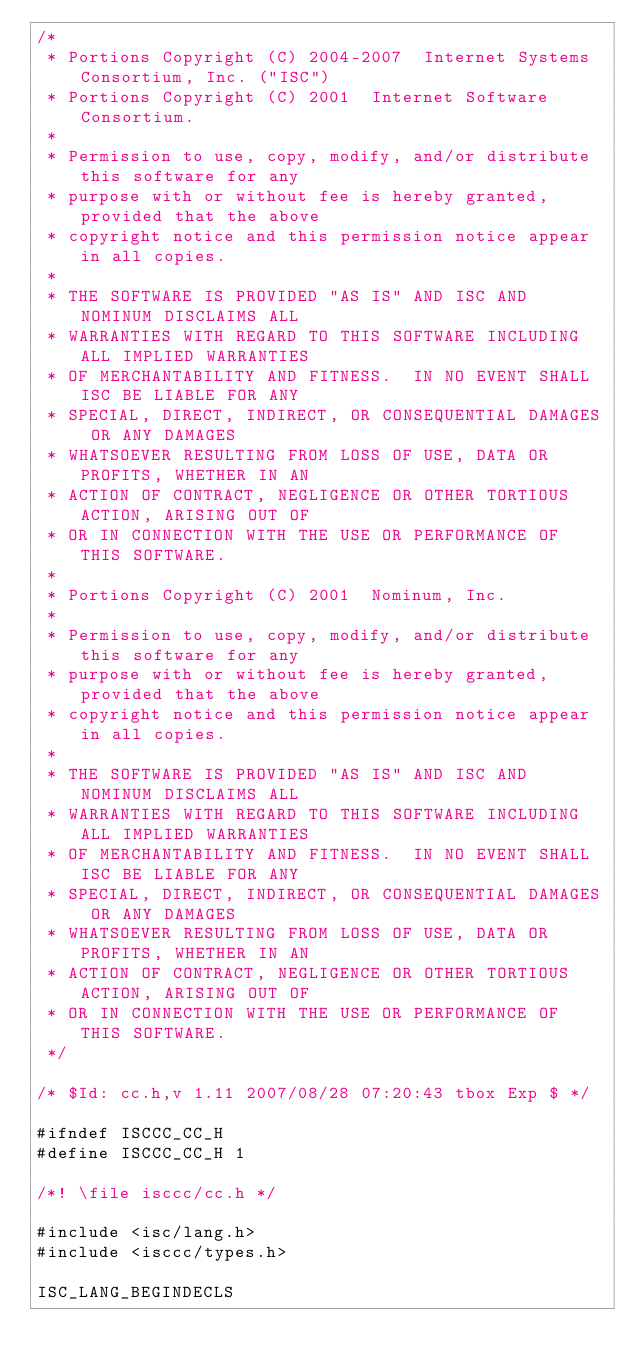Convert code to text. <code><loc_0><loc_0><loc_500><loc_500><_C_>/*
 * Portions Copyright (C) 2004-2007  Internet Systems Consortium, Inc. ("ISC")
 * Portions Copyright (C) 2001  Internet Software Consortium.
 *
 * Permission to use, copy, modify, and/or distribute this software for any
 * purpose with or without fee is hereby granted, provided that the above
 * copyright notice and this permission notice appear in all copies.
 *
 * THE SOFTWARE IS PROVIDED "AS IS" AND ISC AND NOMINUM DISCLAIMS ALL
 * WARRANTIES WITH REGARD TO THIS SOFTWARE INCLUDING ALL IMPLIED WARRANTIES
 * OF MERCHANTABILITY AND FITNESS.  IN NO EVENT SHALL ISC BE LIABLE FOR ANY
 * SPECIAL, DIRECT, INDIRECT, OR CONSEQUENTIAL DAMAGES OR ANY DAMAGES
 * WHATSOEVER RESULTING FROM LOSS OF USE, DATA OR PROFITS, WHETHER IN AN
 * ACTION OF CONTRACT, NEGLIGENCE OR OTHER TORTIOUS ACTION, ARISING OUT OF
 * OR IN CONNECTION WITH THE USE OR PERFORMANCE OF THIS SOFTWARE.
 *
 * Portions Copyright (C) 2001  Nominum, Inc.
 *
 * Permission to use, copy, modify, and/or distribute this software for any
 * purpose with or without fee is hereby granted, provided that the above
 * copyright notice and this permission notice appear in all copies.
 *
 * THE SOFTWARE IS PROVIDED "AS IS" AND ISC AND NOMINUM DISCLAIMS ALL
 * WARRANTIES WITH REGARD TO THIS SOFTWARE INCLUDING ALL IMPLIED WARRANTIES
 * OF MERCHANTABILITY AND FITNESS.  IN NO EVENT SHALL ISC BE LIABLE FOR ANY
 * SPECIAL, DIRECT, INDIRECT, OR CONSEQUENTIAL DAMAGES OR ANY DAMAGES
 * WHATSOEVER RESULTING FROM LOSS OF USE, DATA OR PROFITS, WHETHER IN AN
 * ACTION OF CONTRACT, NEGLIGENCE OR OTHER TORTIOUS ACTION, ARISING OUT OF
 * OR IN CONNECTION WITH THE USE OR PERFORMANCE OF THIS SOFTWARE.
 */

/* $Id: cc.h,v 1.11 2007/08/28 07:20:43 tbox Exp $ */

#ifndef ISCCC_CC_H
#define ISCCC_CC_H 1

/*! \file isccc/cc.h */

#include <isc/lang.h>
#include <isccc/types.h>

ISC_LANG_BEGINDECLS
</code> 